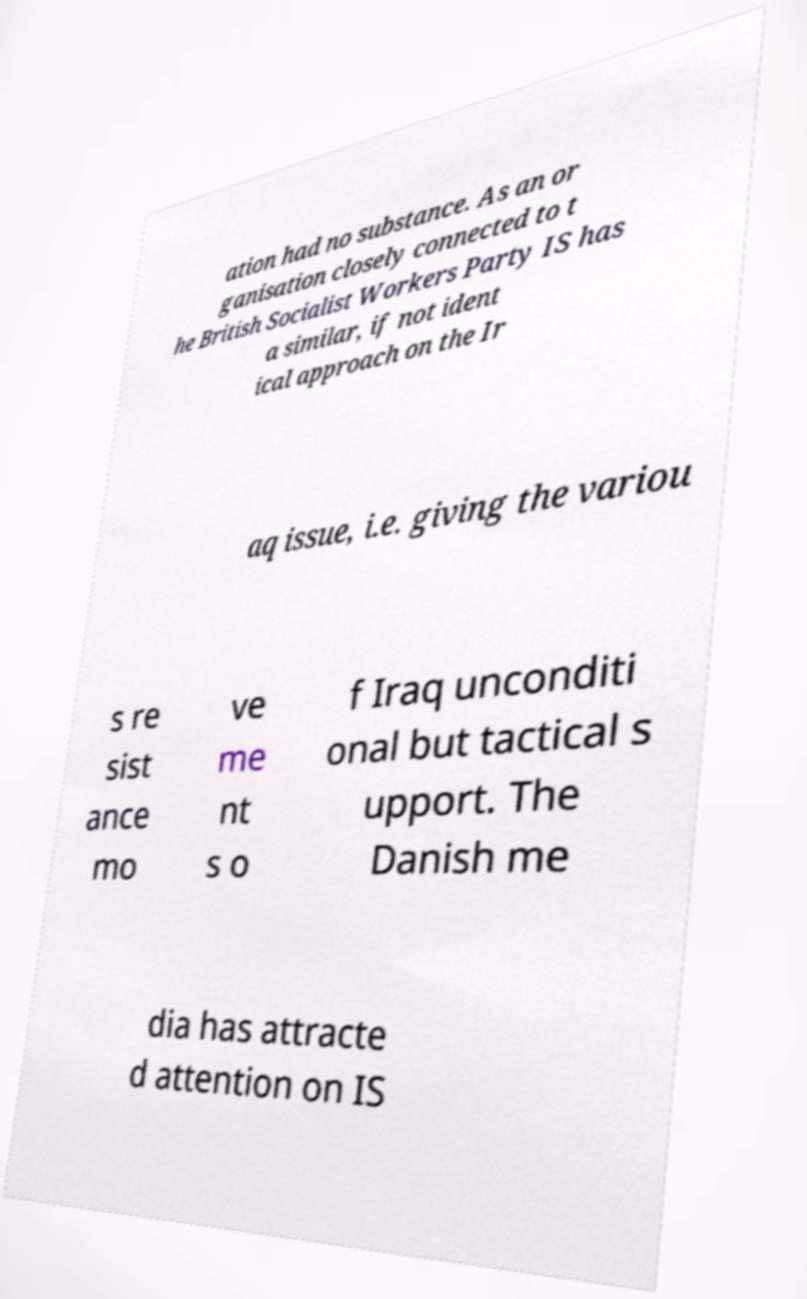What messages or text are displayed in this image? I need them in a readable, typed format. ation had no substance. As an or ganisation closely connected to t he British Socialist Workers Party IS has a similar, if not ident ical approach on the Ir aq issue, i.e. giving the variou s re sist ance mo ve me nt s o f Iraq unconditi onal but tactical s upport. The Danish me dia has attracte d attention on IS 